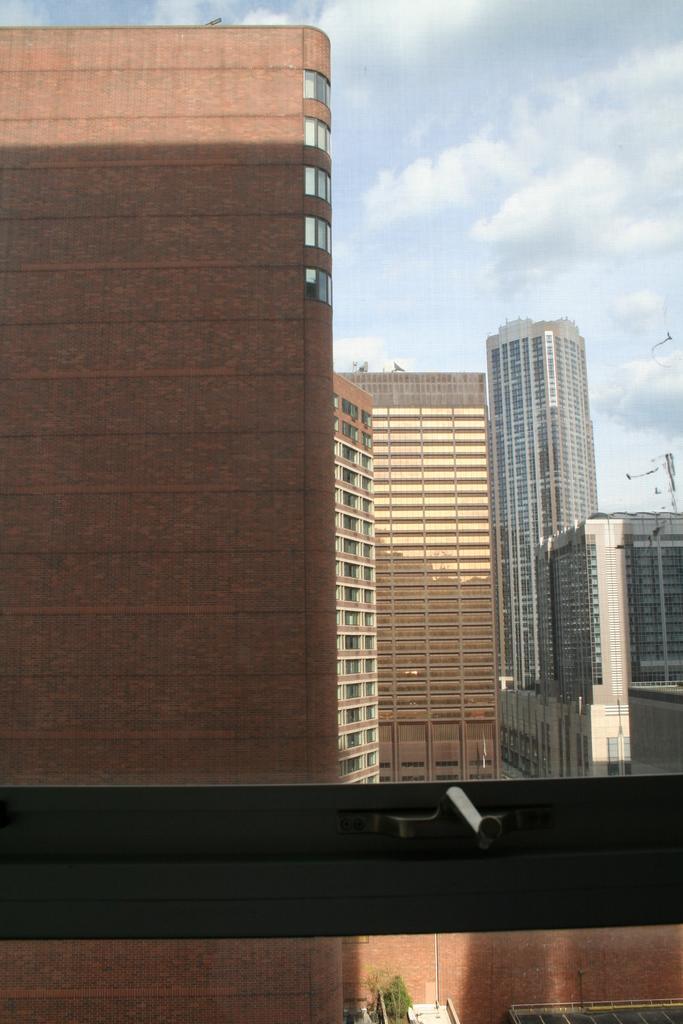Please provide a concise description of this image. In this image we can see there are buildings and there is a plant. On the side there is a pole. In front it looks like a window. At the top there is a sky. 